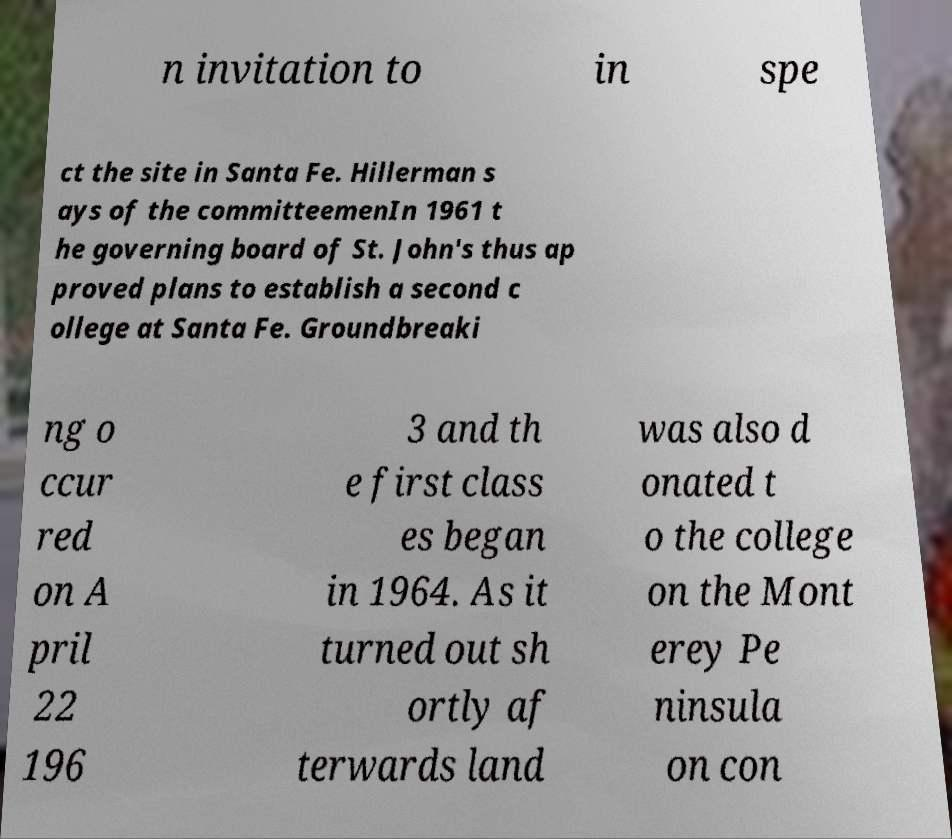Please read and relay the text visible in this image. What does it say? n invitation to in spe ct the site in Santa Fe. Hillerman s ays of the committeemenIn 1961 t he governing board of St. John's thus ap proved plans to establish a second c ollege at Santa Fe. Groundbreaki ng o ccur red on A pril 22 196 3 and th e first class es began in 1964. As it turned out sh ortly af terwards land was also d onated t o the college on the Mont erey Pe ninsula on con 